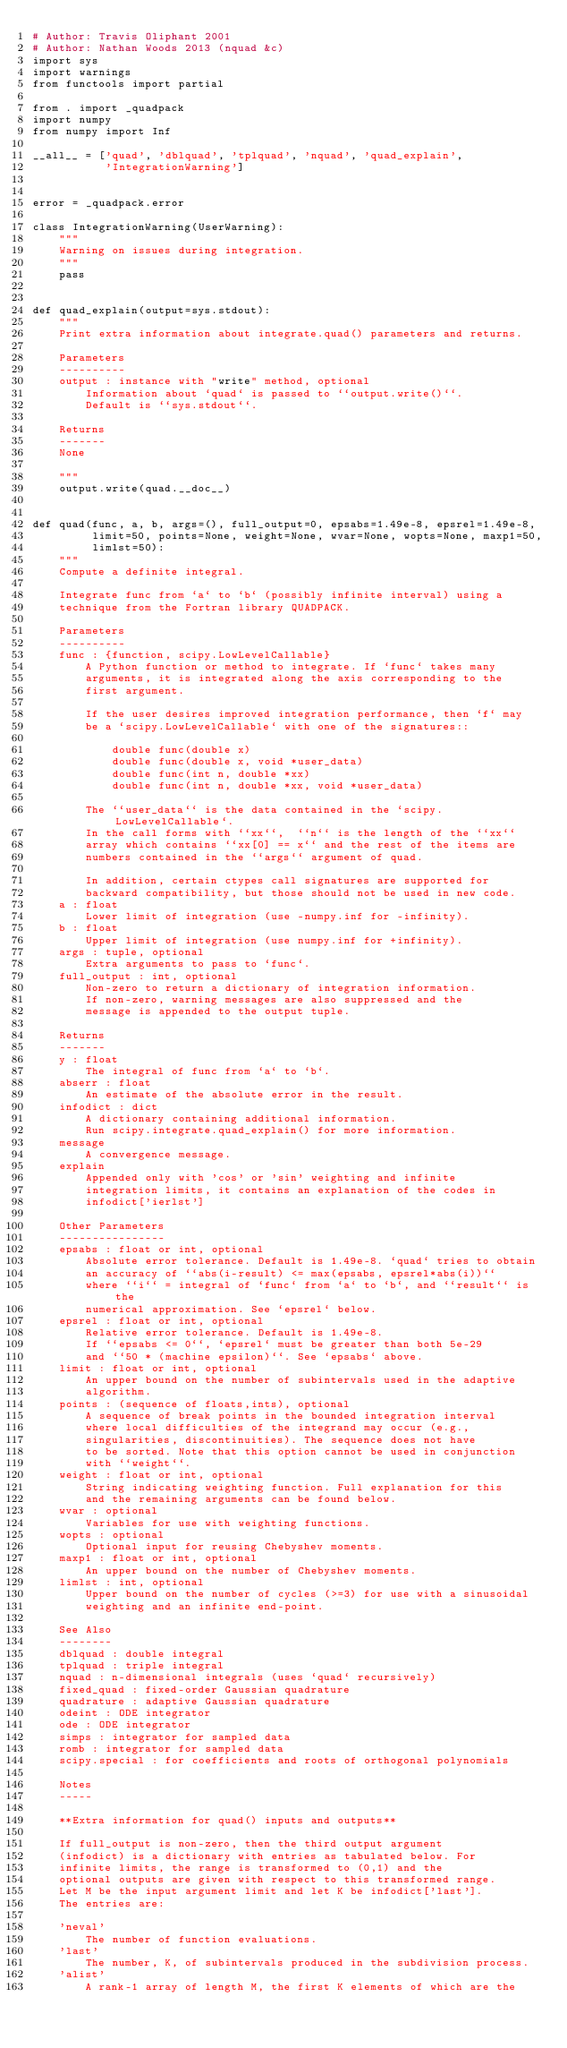Convert code to text. <code><loc_0><loc_0><loc_500><loc_500><_Python_># Author: Travis Oliphant 2001
# Author: Nathan Woods 2013 (nquad &c)
import sys
import warnings
from functools import partial

from . import _quadpack
import numpy
from numpy import Inf

__all__ = ['quad', 'dblquad', 'tplquad', 'nquad', 'quad_explain',
           'IntegrationWarning']


error = _quadpack.error

class IntegrationWarning(UserWarning):
    """
    Warning on issues during integration.
    """
    pass


def quad_explain(output=sys.stdout):
    """
    Print extra information about integrate.quad() parameters and returns.

    Parameters
    ----------
    output : instance with "write" method, optional
        Information about `quad` is passed to ``output.write()``.
        Default is ``sys.stdout``.

    Returns
    -------
    None

    """
    output.write(quad.__doc__)


def quad(func, a, b, args=(), full_output=0, epsabs=1.49e-8, epsrel=1.49e-8,
         limit=50, points=None, weight=None, wvar=None, wopts=None, maxp1=50,
         limlst=50):
    """
    Compute a definite integral.

    Integrate func from `a` to `b` (possibly infinite interval) using a
    technique from the Fortran library QUADPACK.

    Parameters
    ----------
    func : {function, scipy.LowLevelCallable}
        A Python function or method to integrate. If `func` takes many
        arguments, it is integrated along the axis corresponding to the
        first argument.

        If the user desires improved integration performance, then `f` may
        be a `scipy.LowLevelCallable` with one of the signatures::

            double func(double x)
            double func(double x, void *user_data)
            double func(int n, double *xx)
            double func(int n, double *xx, void *user_data)

        The ``user_data`` is the data contained in the `scipy.LowLevelCallable`.
        In the call forms with ``xx``,  ``n`` is the length of the ``xx``
        array which contains ``xx[0] == x`` and the rest of the items are
        numbers contained in the ``args`` argument of quad.

        In addition, certain ctypes call signatures are supported for
        backward compatibility, but those should not be used in new code.
    a : float
        Lower limit of integration (use -numpy.inf for -infinity).
    b : float
        Upper limit of integration (use numpy.inf for +infinity).
    args : tuple, optional
        Extra arguments to pass to `func`.
    full_output : int, optional
        Non-zero to return a dictionary of integration information.
        If non-zero, warning messages are also suppressed and the
        message is appended to the output tuple.

    Returns
    -------
    y : float
        The integral of func from `a` to `b`.
    abserr : float
        An estimate of the absolute error in the result.
    infodict : dict
        A dictionary containing additional information.
        Run scipy.integrate.quad_explain() for more information.
    message
        A convergence message.
    explain
        Appended only with 'cos' or 'sin' weighting and infinite
        integration limits, it contains an explanation of the codes in
        infodict['ierlst']

    Other Parameters
    ----------------
    epsabs : float or int, optional
        Absolute error tolerance. Default is 1.49e-8. `quad` tries to obtain
        an accuracy of ``abs(i-result) <= max(epsabs, epsrel*abs(i))``
        where ``i`` = integral of `func` from `a` to `b`, and ``result`` is the
        numerical approximation. See `epsrel` below.
    epsrel : float or int, optional
        Relative error tolerance. Default is 1.49e-8.
        If ``epsabs <= 0``, `epsrel` must be greater than both 5e-29
        and ``50 * (machine epsilon)``. See `epsabs` above.
    limit : float or int, optional
        An upper bound on the number of subintervals used in the adaptive
        algorithm.
    points : (sequence of floats,ints), optional
        A sequence of break points in the bounded integration interval
        where local difficulties of the integrand may occur (e.g.,
        singularities, discontinuities). The sequence does not have
        to be sorted. Note that this option cannot be used in conjunction
        with ``weight``.
    weight : float or int, optional
        String indicating weighting function. Full explanation for this
        and the remaining arguments can be found below.
    wvar : optional
        Variables for use with weighting functions.
    wopts : optional
        Optional input for reusing Chebyshev moments.
    maxp1 : float or int, optional
        An upper bound on the number of Chebyshev moments.
    limlst : int, optional
        Upper bound on the number of cycles (>=3) for use with a sinusoidal
        weighting and an infinite end-point.

    See Also
    --------
    dblquad : double integral
    tplquad : triple integral
    nquad : n-dimensional integrals (uses `quad` recursively)
    fixed_quad : fixed-order Gaussian quadrature
    quadrature : adaptive Gaussian quadrature
    odeint : ODE integrator
    ode : ODE integrator
    simps : integrator for sampled data
    romb : integrator for sampled data
    scipy.special : for coefficients and roots of orthogonal polynomials

    Notes
    -----

    **Extra information for quad() inputs and outputs**

    If full_output is non-zero, then the third output argument
    (infodict) is a dictionary with entries as tabulated below. For
    infinite limits, the range is transformed to (0,1) and the
    optional outputs are given with respect to this transformed range.
    Let M be the input argument limit and let K be infodict['last'].
    The entries are:

    'neval'
        The number of function evaluations.
    'last'
        The number, K, of subintervals produced in the subdivision process.
    'alist'
        A rank-1 array of length M, the first K elements of which are the</code> 